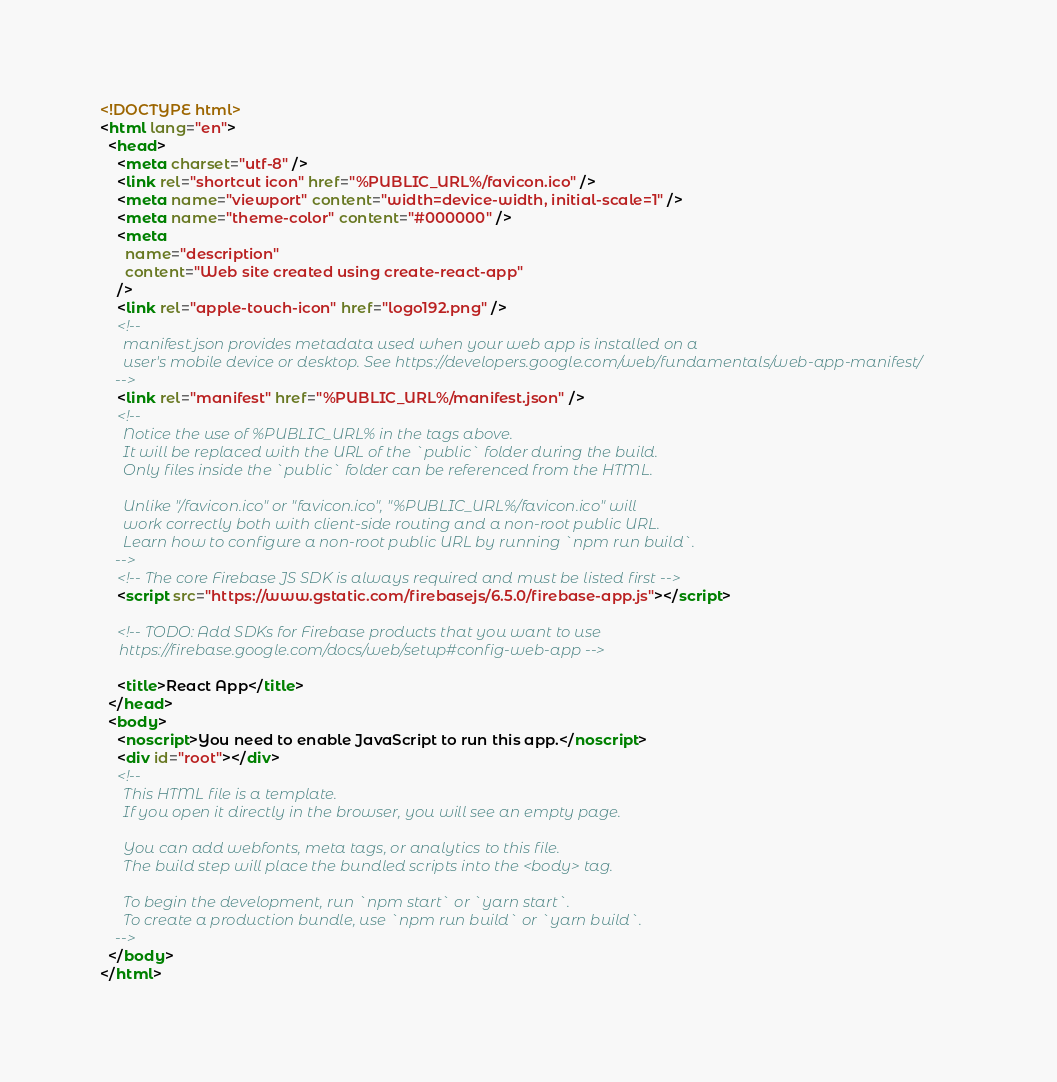Convert code to text. <code><loc_0><loc_0><loc_500><loc_500><_HTML_><!DOCTYPE html>
<html lang="en">
  <head>
    <meta charset="utf-8" />
    <link rel="shortcut icon" href="%PUBLIC_URL%/favicon.ico" />
    <meta name="viewport" content="width=device-width, initial-scale=1" />
    <meta name="theme-color" content="#000000" />
    <meta
      name="description"
      content="Web site created using create-react-app"
    />
    <link rel="apple-touch-icon" href="logo192.png" />
    <!--
      manifest.json provides metadata used when your web app is installed on a
      user's mobile device or desktop. See https://developers.google.com/web/fundamentals/web-app-manifest/
    -->
    <link rel="manifest" href="%PUBLIC_URL%/manifest.json" />
    <!--
      Notice the use of %PUBLIC_URL% in the tags above.
      It will be replaced with the URL of the `public` folder during the build.
      Only files inside the `public` folder can be referenced from the HTML.

      Unlike "/favicon.ico" or "favicon.ico", "%PUBLIC_URL%/favicon.ico" will
      work correctly both with client-side routing and a non-root public URL.
      Learn how to configure a non-root public URL by running `npm run build`.
    -->
    <!-- The core Firebase JS SDK is always required and must be listed first -->
    <script src="https://www.gstatic.com/firebasejs/6.5.0/firebase-app.js"></script>

    <!-- TODO: Add SDKs for Firebase products that you want to use
     https://firebase.google.com/docs/web/setup#config-web-app -->

    <title>React App</title>
  </head>
  <body>
    <noscript>You need to enable JavaScript to run this app.</noscript>
    <div id="root"></div>
    <!--
      This HTML file is a template.
      If you open it directly in the browser, you will see an empty page.

      You can add webfonts, meta tags, or analytics to this file.
      The build step will place the bundled scripts into the <body> tag.

      To begin the development, run `npm start` or `yarn start`.
      To create a production bundle, use `npm run build` or `yarn build`.
    -->
  </body>
</html>
</code> 